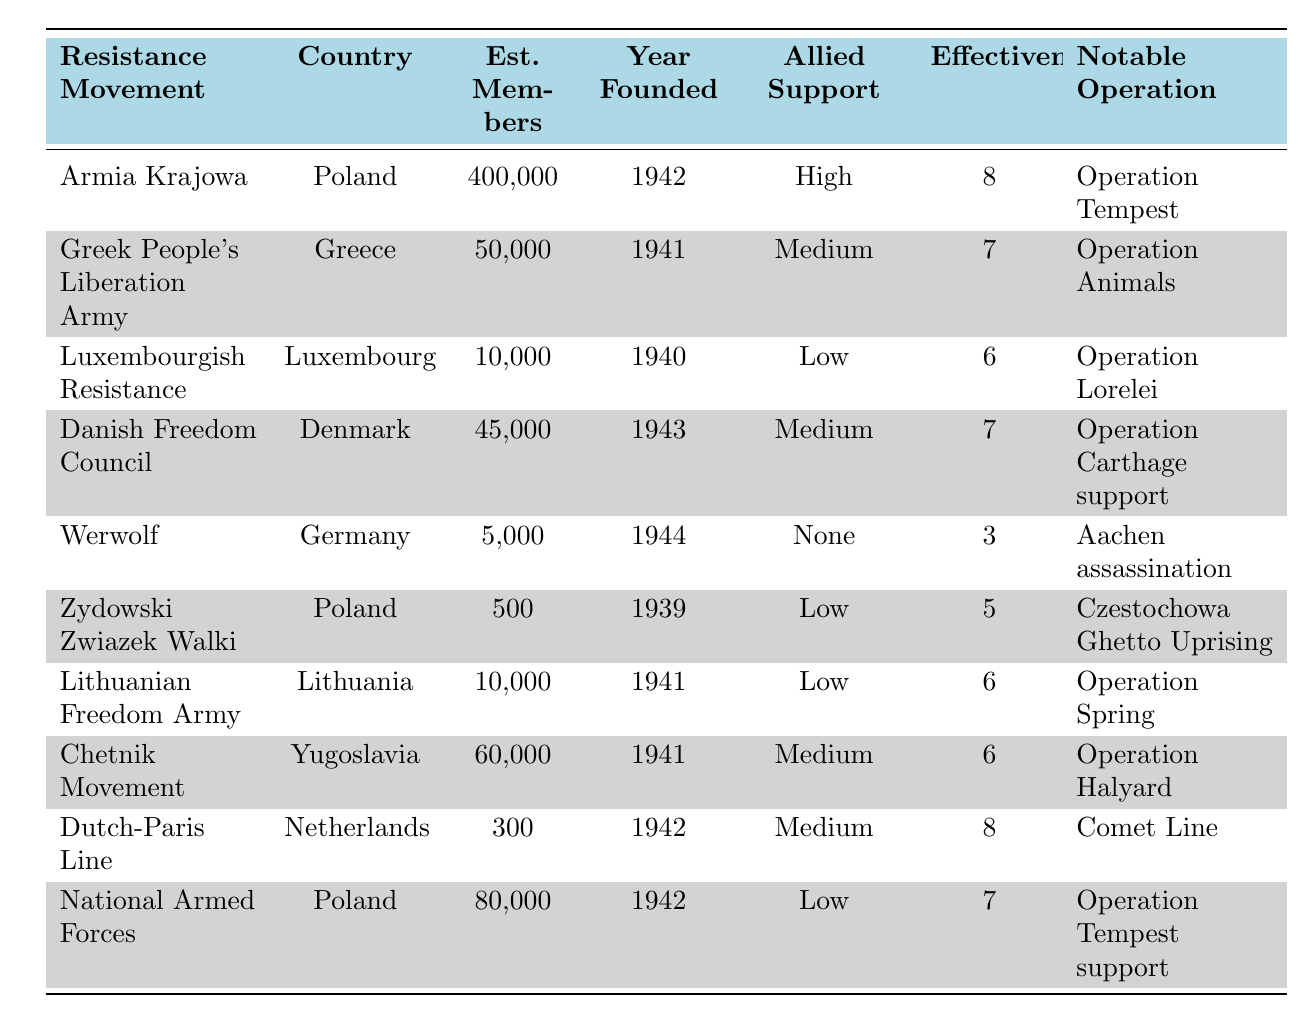What country has the resistance movement with the highest estimated number of members? According to the table, the resistance movement with the highest estimated members is "Armia Krajowa" from Poland, with an estimated 400,000 members.
Answer: Poland Which resistance movement was founded in 1941 and had low allied support? The movement "Lithuanian Freedom Army," founded in 1941, had low allied support, according to the table.
Answer: Lithuanian Freedom Army What is the average effectiveness rating of the resistance movements from Poland? The effectiveness ratings for resistance movements from Poland are 8 (Armia Krajowa), 5 (Zydowski Zwiazek Walki), and 7 (National Armed Forces). To calculate the average, we add these ratings: 8 + 5 + 7 = 20, and then divide by the number of movements (3). Thus, the average effectiveness rating is 20/3 = 6.67.
Answer: 6.67 Which resistance movement has the lowest estimated number of members and what is its effectiveness rating? The "Dutch-Paris Line" has the lowest estimated number of members at 300, and its effectiveness rating is 8.
Answer: Dutch-Paris Line, 8 True or False: The "Werwolf" movement was founded in 1944. The table lists "Werwolf" as having been founded in 1944, making the statement true.
Answer: True What notable operation is associated with the "Chetnik Movement"? The notable operation associated with the "Chetnik Movement" is "Operation Halyard," as mentioned in the table.
Answer: Operation Halyard How many of the resistance movements listed have high allied support? There are two movements with high allied support: "Armia Krajowa" and "Dutch-Paris Line." Counting these gives us a total of 2 movements.
Answer: 2 What is the total estimated membership of all resistance movements founded in 1941? The estimated memberships for movements founded in 1941 are "Greek People's Liberation Army" (50,000), "Lithuanian Freedom Army" (10,000), and "Chetnik Movement" (60,000). Summing these gives 50,000 + 10,000 + 60,000 = 120,000, so the total estimated membership is 120,000.
Answer: 120,000 